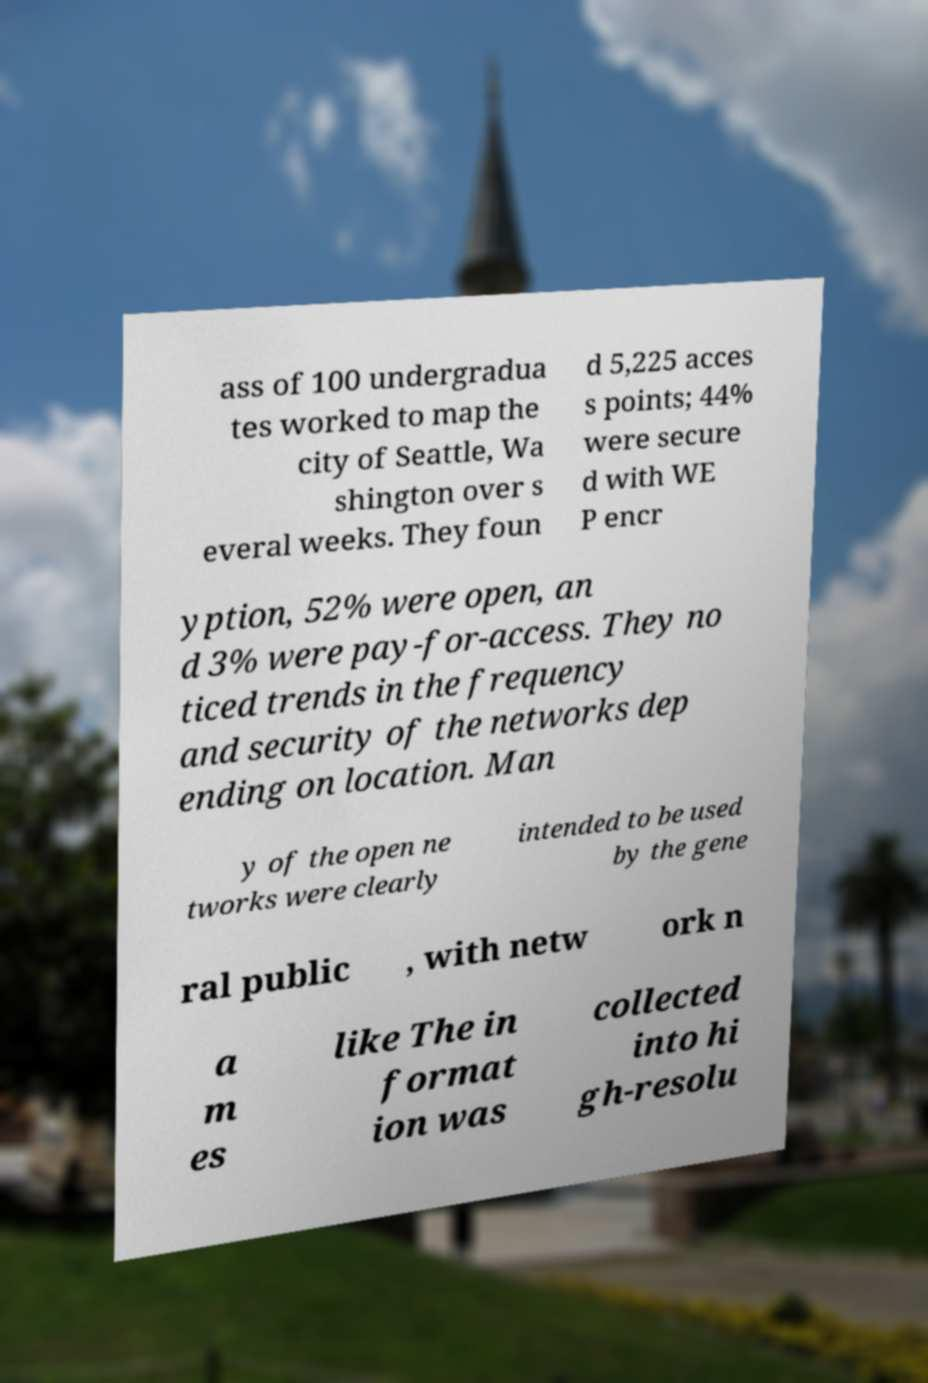I need the written content from this picture converted into text. Can you do that? ass of 100 undergradua tes worked to map the city of Seattle, Wa shington over s everal weeks. They foun d 5,225 acces s points; 44% were secure d with WE P encr yption, 52% were open, an d 3% were pay-for-access. They no ticed trends in the frequency and security of the networks dep ending on location. Man y of the open ne tworks were clearly intended to be used by the gene ral public , with netw ork n a m es like The in format ion was collected into hi gh-resolu 